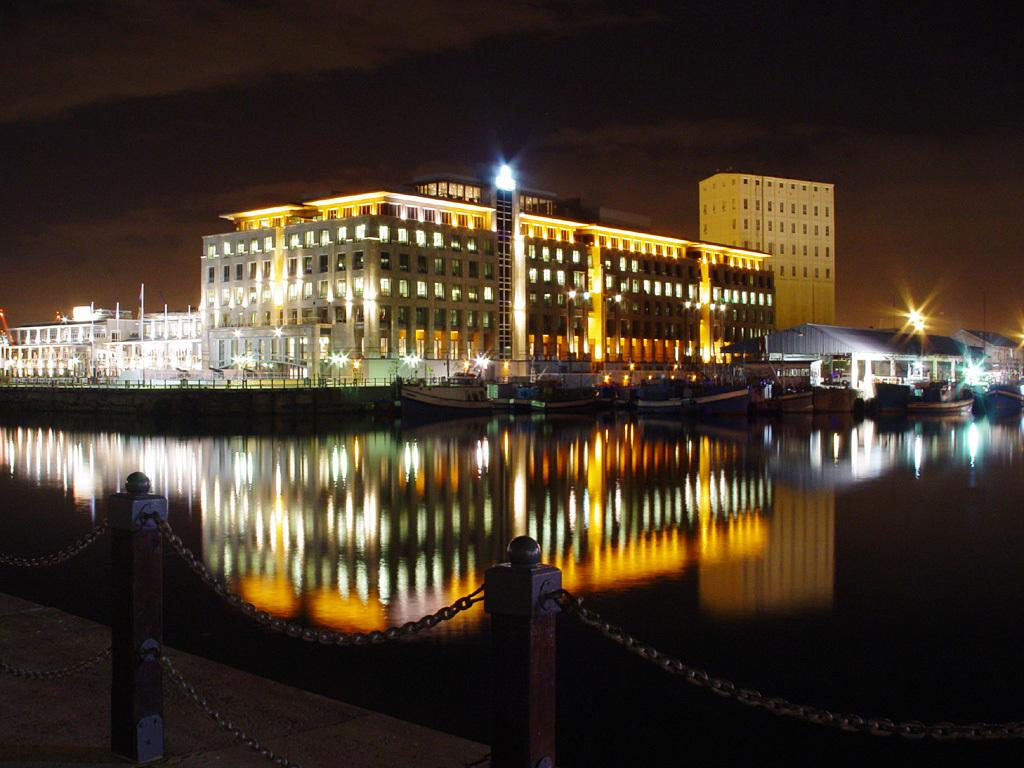What is located in the front of the image? There is water and a chain railing in the front of the image. What can be seen in the background of the image? There are buildings, boats, lights, and a dark sky in the background of the image. How are the boats positioned in the image? The boats are floating on the water in the background of the image. What month is it in the image? The month cannot be determined from the image, as there is no information about the time of year. Can you see a rake in the image? There is no rake present in the image. 